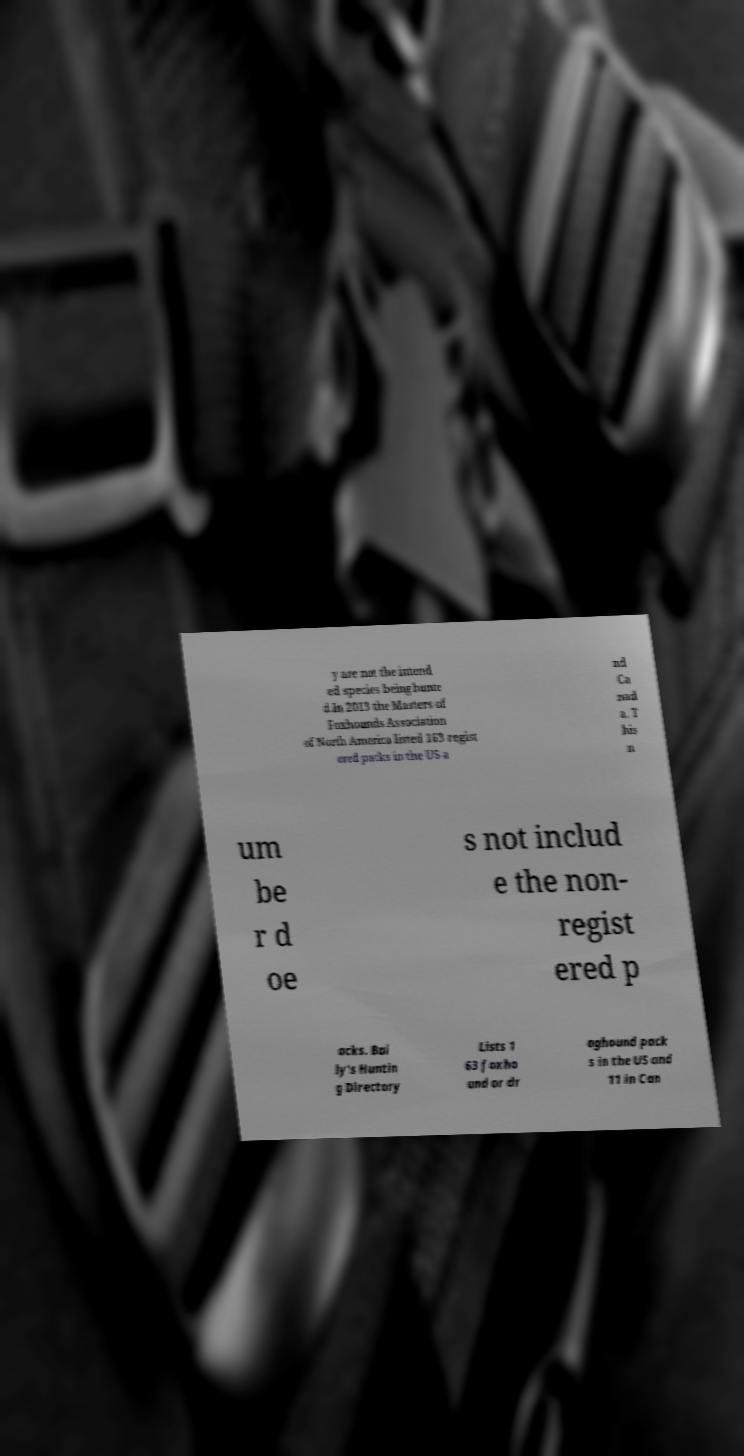What messages or text are displayed in this image? I need them in a readable, typed format. y are not the intend ed species being hunte d.In 2013 the Masters of Foxhounds Association of North America listed 163 regist ered packs in the US a nd Ca nad a. T his n um be r d oe s not includ e the non- regist ered p acks. Bai ly's Huntin g Directory Lists 1 63 foxho und or dr aghound pack s in the US and 11 in Can 